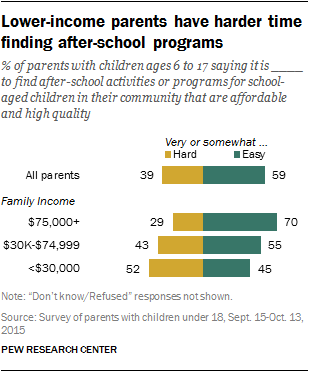Give some essential details in this illustration. In the very hard scenario, the poorest income group is more than twice as rich as the richest income group. The difference between the largest green bar and the smallest yellow bar is 41. 